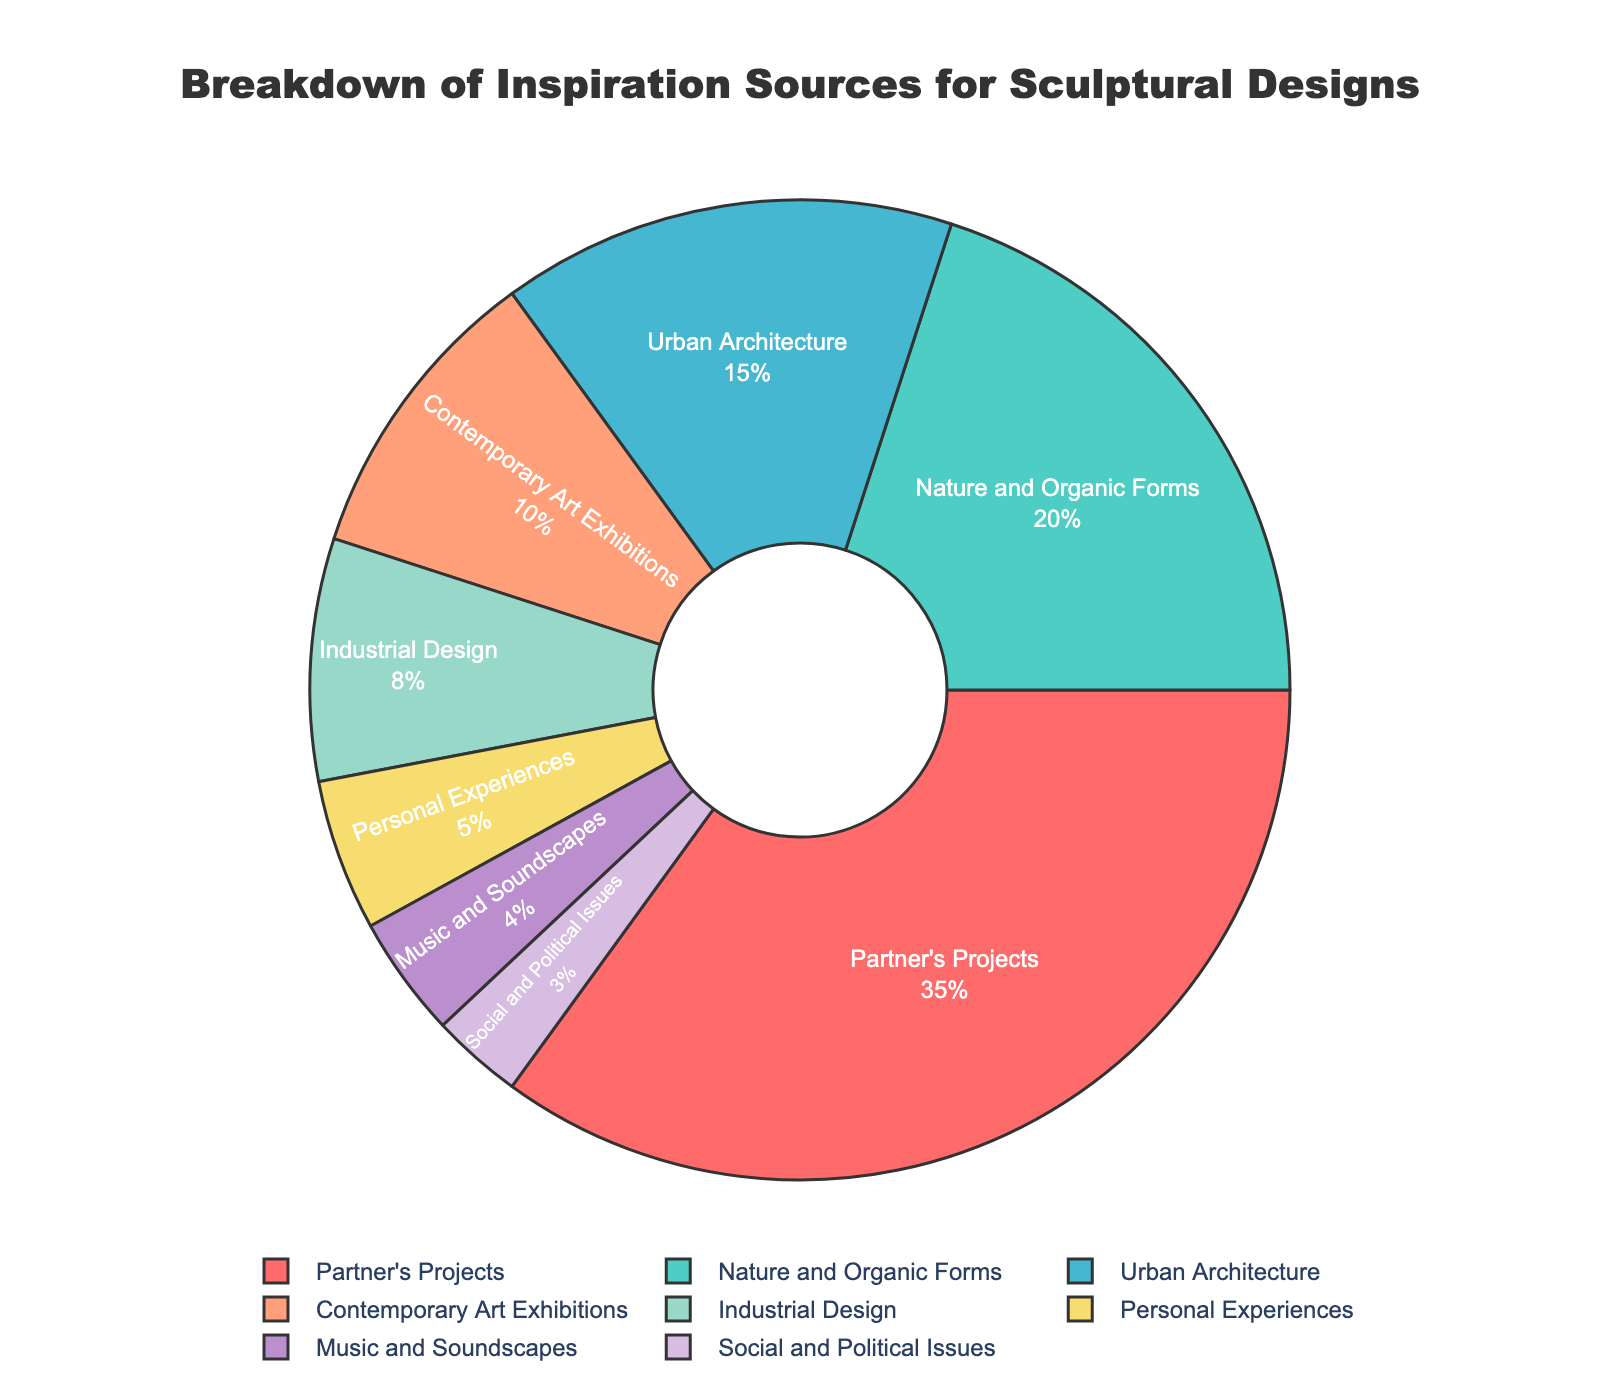Which inspiration source occupies the largest percentage in the pie chart? By visually inspecting the pie chart, the segment labeled "Partner's Projects" looks the largest. According to the figure, "Partner's Projects" holds the largest percentage at 35%.
Answer: Partner's Projects What is the combined percentage of inspiration sources from "Nature and Organic Forms" and "Urban Architecture"? Add the percentages of "Nature and Organic Forms" (20%) and "Urban Architecture" (15%). The combined percentage is 20 + 15 = 35%.
Answer: 35% Which inspiration source has the smallest representation in the pie chart? By looking at the pie chart, the smallest segment is labeled "Social and Political Issues" with 3%.
Answer: Social and Political Issues Are the inspiration sources from "Nature and Organic Forms" and "Industrial Design" greater than "Partner's Projects"? Add the percentages for "Nature and Organic Forms" (20%) and "Industrial Design" (8%). The combined value is 28%, which is less than "Partner's Projects" (35%).
Answer: No What is the difference in percentage between "Contemporary Art Exhibitions" and "Personal Experiences"? Subtract the percentage of "Personal Experiences" (5%) from "Contemporary Art Exhibitions" (10%). The difference is 10 - 5 = 5%.
Answer: 5% Which three inspiration sources together make up more than half of the pie chart? Add the percentages of the top three sources: "Partner's Projects" (35%), "Nature and Organic Forms" (20%), and "Urban Architecture" (15%). The combined value is 35 + 20 + 15 = 70%, which is more than 50%.
Answer: Partner's Projects, Nature and Organic Forms, Urban Architecture Is the percentage of "Music and Soundscapes" greater than that of "Personal Experiences"? Compare the two percentages: "Music and Soundscapes" (4%) and "Personal Experiences" (5%). The former is smaller than the latter.
Answer: No What is the average percentage of inspiration sources excluding "Partner's Projects"? Sum the percentages of all other sources (20 + 15 + 10 + 8 + 5 + 4 + 3 = 65) and divide by the number of those sources (7). The average is 65/7 ≈ 9.29%.
Answer: 9.29% What color is used for the "Social and Political Issues" segment in the pie chart? By identifying the colors in the pie chart and matching them to the labels, the segment for "Social and Political Issues" appears to be a shade of purple.
Answer: Purple How much more popular is "Industrial Design" compared to "Social and Political Issues"? Subtract the percentage of "Social and Political Issues" (3%) from "Industrial Design" (8%). The difference is 8 - 3 = 5%.
Answer: 5% 